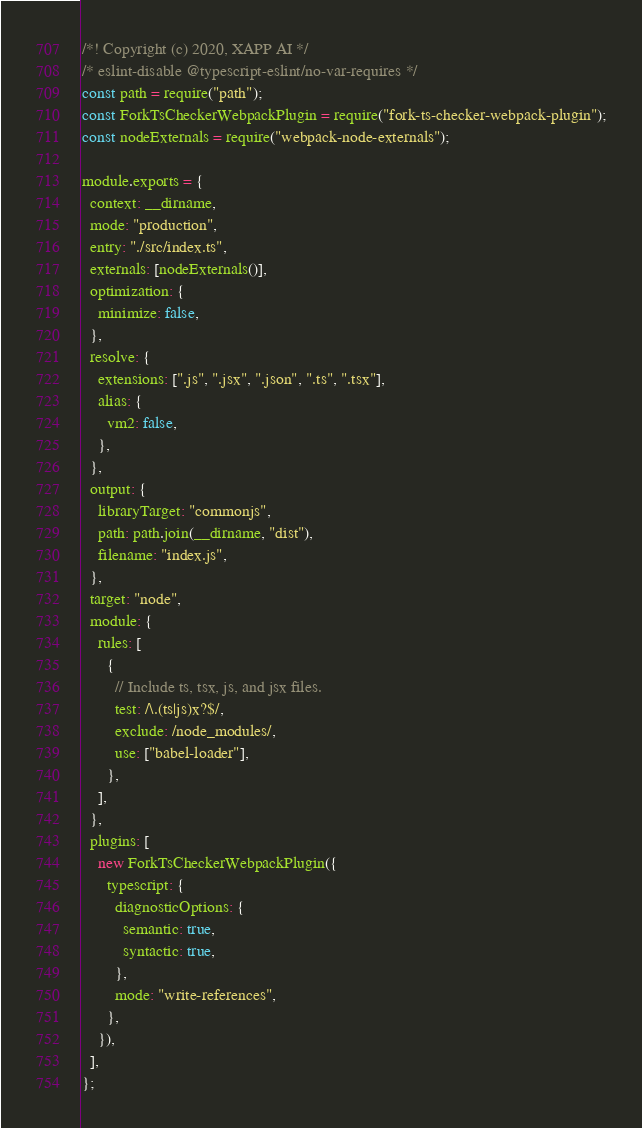<code> <loc_0><loc_0><loc_500><loc_500><_JavaScript_>/*! Copyright (c) 2020, XAPP AI */
/* eslint-disable @typescript-eslint/no-var-requires */
const path = require("path");
const ForkTsCheckerWebpackPlugin = require("fork-ts-checker-webpack-plugin");
const nodeExternals = require("webpack-node-externals");

module.exports = {
  context: __dirname,
  mode: "production",
  entry: "./src/index.ts",
  externals: [nodeExternals()],
  optimization: {
    minimize: false,
  },
  resolve: {
    extensions: [".js", ".jsx", ".json", ".ts", ".tsx"],
    alias: {
      vm2: false,
    },
  },
  output: {
    libraryTarget: "commonjs",
    path: path.join(__dirname, "dist"),
    filename: "index.js",
  },
  target: "node",
  module: {
    rules: [
      {
        // Include ts, tsx, js, and jsx files.
        test: /\.(ts|js)x?$/,
        exclude: /node_modules/,
        use: ["babel-loader"],
      },
    ],
  },
  plugins: [
    new ForkTsCheckerWebpackPlugin({
      typescript: {
        diagnosticOptions: {
          semantic: true,
          syntactic: true,
        },
        mode: "write-references",
      },
    }),
  ],
};
</code> 